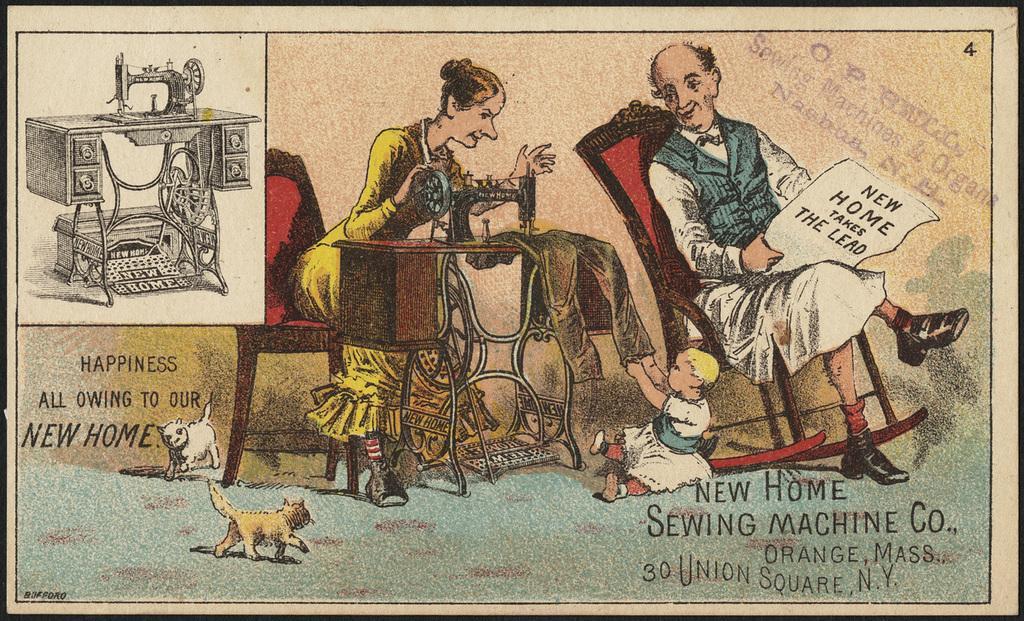Describe this image in one or two sentences. This is a cartoon image. In this image I can see a man and a woman are sitting. Here I can see a baby. On the left side I can see a animals and machines. I can also see something written on the image. 